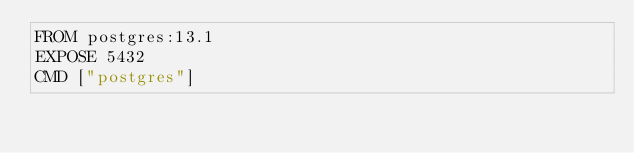Convert code to text. <code><loc_0><loc_0><loc_500><loc_500><_Dockerfile_>FROM postgres:13.1
EXPOSE 5432
CMD ["postgres"]</code> 